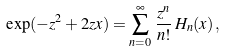<formula> <loc_0><loc_0><loc_500><loc_500>\exp ( - z ^ { 2 } + 2 z x ) = \sum _ { n = 0 } ^ { \infty } \, \frac { z ^ { n } } { n ! } \, H _ { n } ( x ) \, ,</formula> 